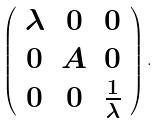<formula> <loc_0><loc_0><loc_500><loc_500>\left ( \begin{array} { c c c } \lambda & 0 & 0 \\ 0 & A & 0 \\ 0 & 0 & \frac { 1 } { \lambda } \end{array} \right ) .</formula> 